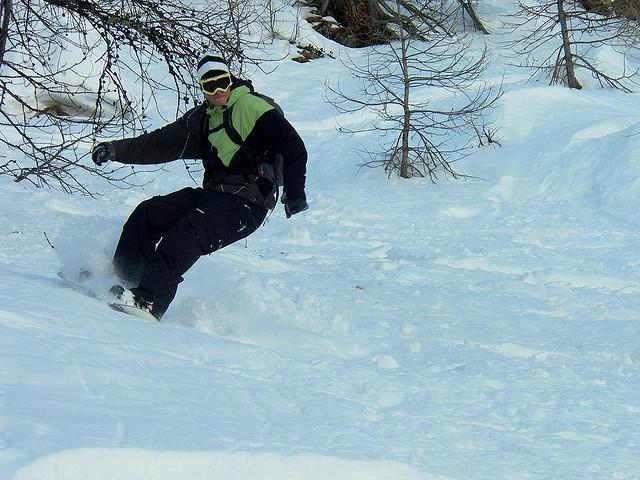What is the man wearing?
Indicate the correct response by choosing from the four available options to answer the question.
Options: Goggles, bandana, potato sack, garbage bag. Goggles. 